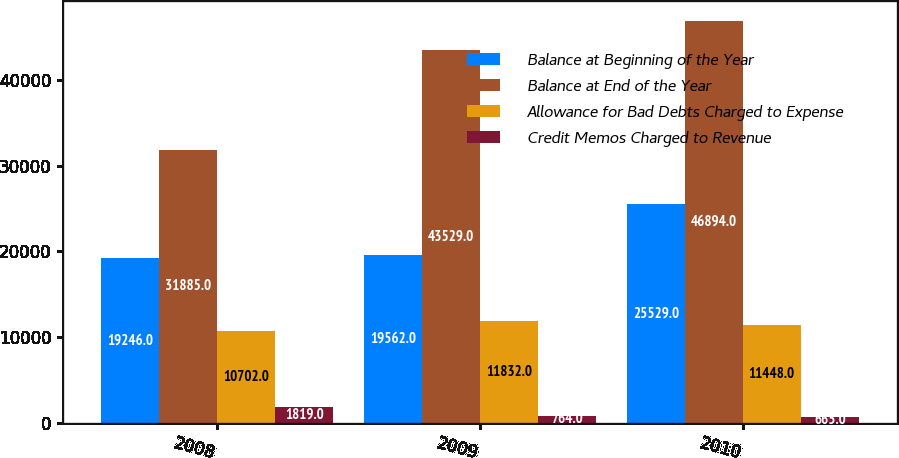Convert chart to OTSL. <chart><loc_0><loc_0><loc_500><loc_500><stacked_bar_chart><ecel><fcel>2008<fcel>2009<fcel>2010<nl><fcel>Balance at Beginning of the Year<fcel>19246<fcel>19562<fcel>25529<nl><fcel>Balance at End of the Year<fcel>31885<fcel>43529<fcel>46894<nl><fcel>Allowance for Bad Debts Charged to Expense<fcel>10702<fcel>11832<fcel>11448<nl><fcel>Credit Memos Charged to Revenue<fcel>1819<fcel>764<fcel>665<nl></chart> 